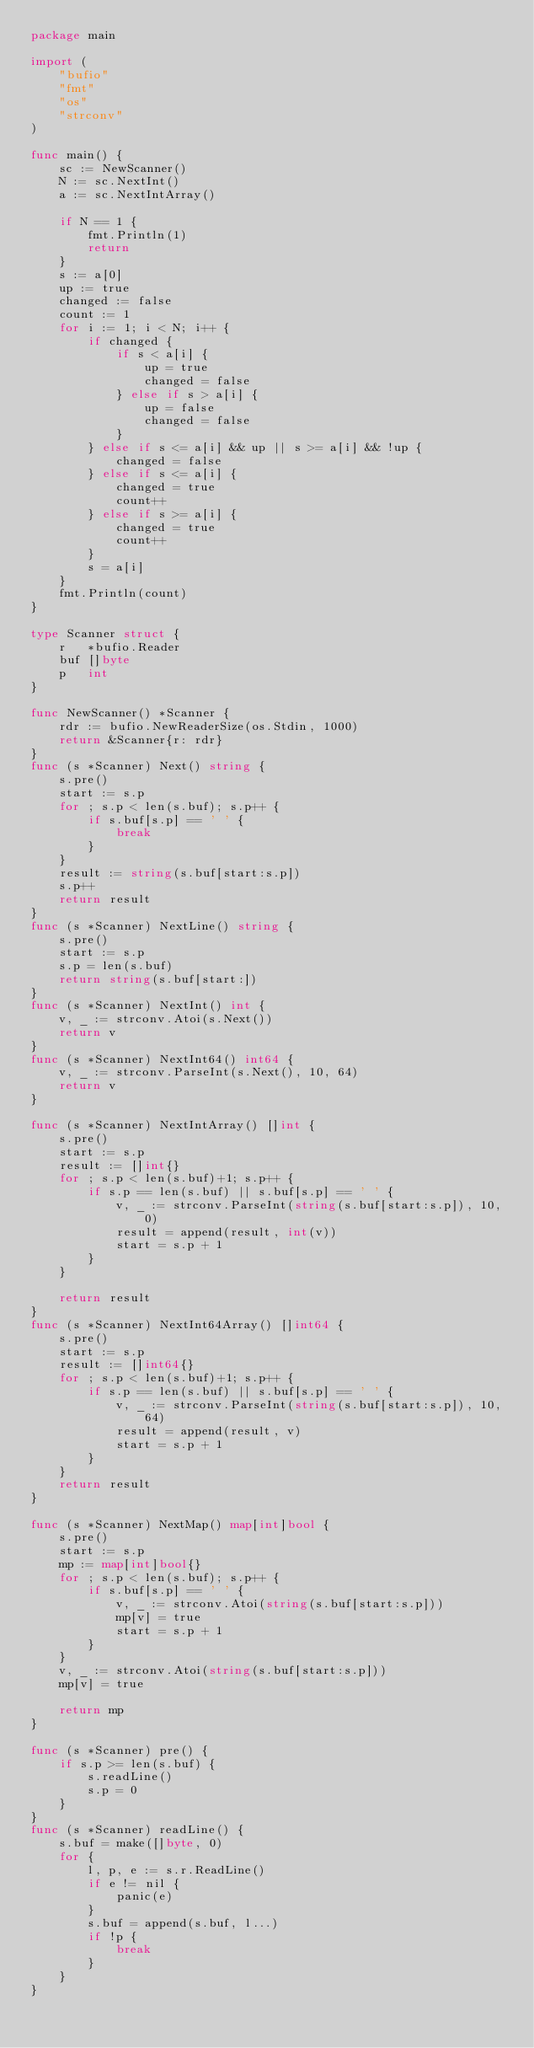Convert code to text. <code><loc_0><loc_0><loc_500><loc_500><_Go_>package main

import (
	"bufio"
	"fmt"
	"os"
	"strconv"
)

func main() {
	sc := NewScanner()
	N := sc.NextInt()
	a := sc.NextIntArray()

	if N == 1 {
		fmt.Println(1)
		return
	}
	s := a[0]
	up := true
	changed := false
	count := 1
	for i := 1; i < N; i++ {
		if changed {
			if s < a[i] {
				up = true
				changed = false
			} else if s > a[i] {
				up = false
				changed = false
			}
		} else if s <= a[i] && up || s >= a[i] && !up {
			changed = false
		} else if s <= a[i] {
			changed = true
			count++
		} else if s >= a[i] {
			changed = true
			count++
		}
		s = a[i]
	}
	fmt.Println(count)
}

type Scanner struct {
	r   *bufio.Reader
	buf []byte
	p   int
}

func NewScanner() *Scanner {
	rdr := bufio.NewReaderSize(os.Stdin, 1000)
	return &Scanner{r: rdr}
}
func (s *Scanner) Next() string {
	s.pre()
	start := s.p
	for ; s.p < len(s.buf); s.p++ {
		if s.buf[s.p] == ' ' {
			break
		}
	}
	result := string(s.buf[start:s.p])
	s.p++
	return result
}
func (s *Scanner) NextLine() string {
	s.pre()
	start := s.p
	s.p = len(s.buf)
	return string(s.buf[start:])
}
func (s *Scanner) NextInt() int {
	v, _ := strconv.Atoi(s.Next())
	return v
}
func (s *Scanner) NextInt64() int64 {
	v, _ := strconv.ParseInt(s.Next(), 10, 64)
	return v
}

func (s *Scanner) NextIntArray() []int {
	s.pre()
	start := s.p
	result := []int{}
	for ; s.p < len(s.buf)+1; s.p++ {
		if s.p == len(s.buf) || s.buf[s.p] == ' ' {
			v, _ := strconv.ParseInt(string(s.buf[start:s.p]), 10, 0)
			result = append(result, int(v))
			start = s.p + 1
		}
	}

	return result
}
func (s *Scanner) NextInt64Array() []int64 {
	s.pre()
	start := s.p
	result := []int64{}
	for ; s.p < len(s.buf)+1; s.p++ {
		if s.p == len(s.buf) || s.buf[s.p] == ' ' {
			v, _ := strconv.ParseInt(string(s.buf[start:s.p]), 10, 64)
			result = append(result, v)
			start = s.p + 1
		}
	}
	return result
}

func (s *Scanner) NextMap() map[int]bool {
	s.pre()
	start := s.p
	mp := map[int]bool{}
	for ; s.p < len(s.buf); s.p++ {
		if s.buf[s.p] == ' ' {
			v, _ := strconv.Atoi(string(s.buf[start:s.p]))
			mp[v] = true
			start = s.p + 1
		}
	}
	v, _ := strconv.Atoi(string(s.buf[start:s.p]))
	mp[v] = true

	return mp
}

func (s *Scanner) pre() {
	if s.p >= len(s.buf) {
		s.readLine()
		s.p = 0
	}
}
func (s *Scanner) readLine() {
	s.buf = make([]byte, 0)
	for {
		l, p, e := s.r.ReadLine()
		if e != nil {
			panic(e)
		}
		s.buf = append(s.buf, l...)
		if !p {
			break
		}
	}
}
</code> 